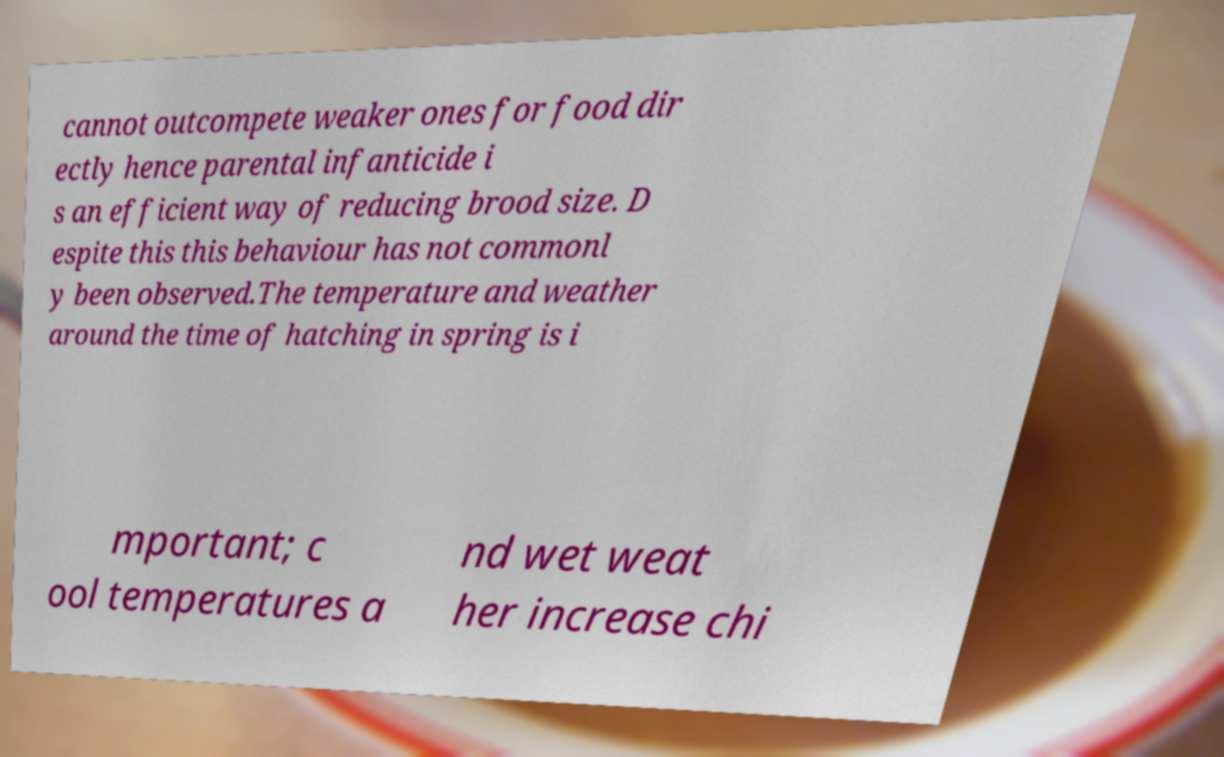What messages or text are displayed in this image? I need them in a readable, typed format. cannot outcompete weaker ones for food dir ectly hence parental infanticide i s an efficient way of reducing brood size. D espite this this behaviour has not commonl y been observed.The temperature and weather around the time of hatching in spring is i mportant; c ool temperatures a nd wet weat her increase chi 